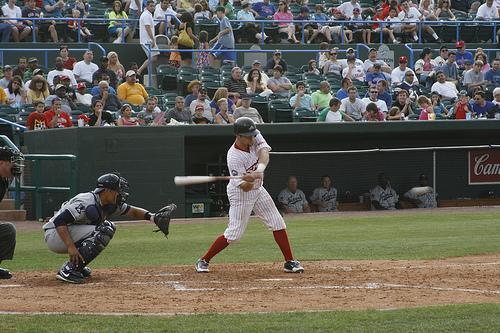How many baseball bats are there?
Give a very brief answer. 1. 